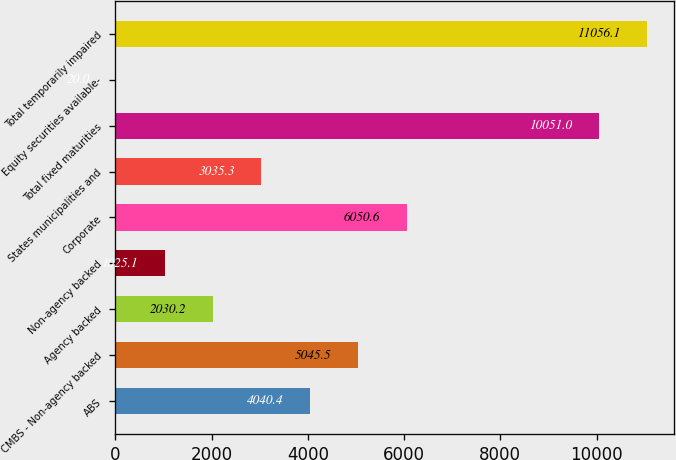<chart> <loc_0><loc_0><loc_500><loc_500><bar_chart><fcel>ABS<fcel>CMBS - Non-agency backed<fcel>Agency backed<fcel>Non-agency backed<fcel>Corporate<fcel>States municipalities and<fcel>Total fixed maturities<fcel>Equity securities available-<fcel>Total temporarily impaired<nl><fcel>4040.4<fcel>5045.5<fcel>2030.2<fcel>1025.1<fcel>6050.6<fcel>3035.3<fcel>10051<fcel>20<fcel>11056.1<nl></chart> 